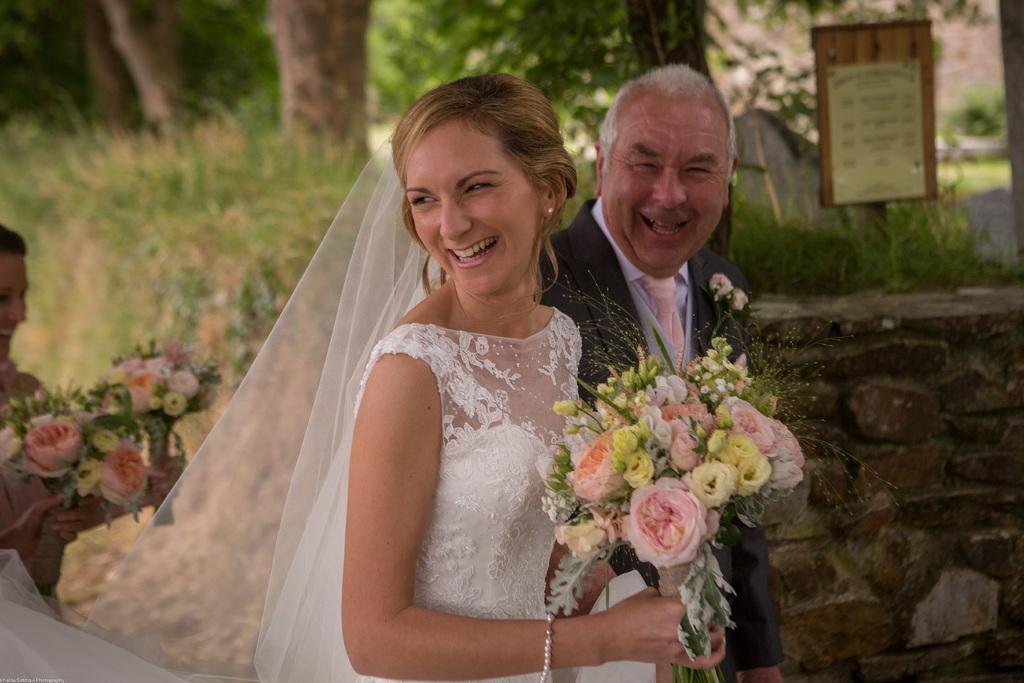Can you describe this image briefly? In this picture I can see a man and a woman are smiling. The woman is wearing white color dress and holding flowers in the hand. On the right side I can see a wall, grass and a board. On the left side I can see a woman is holding flower bokeh in the hands. 